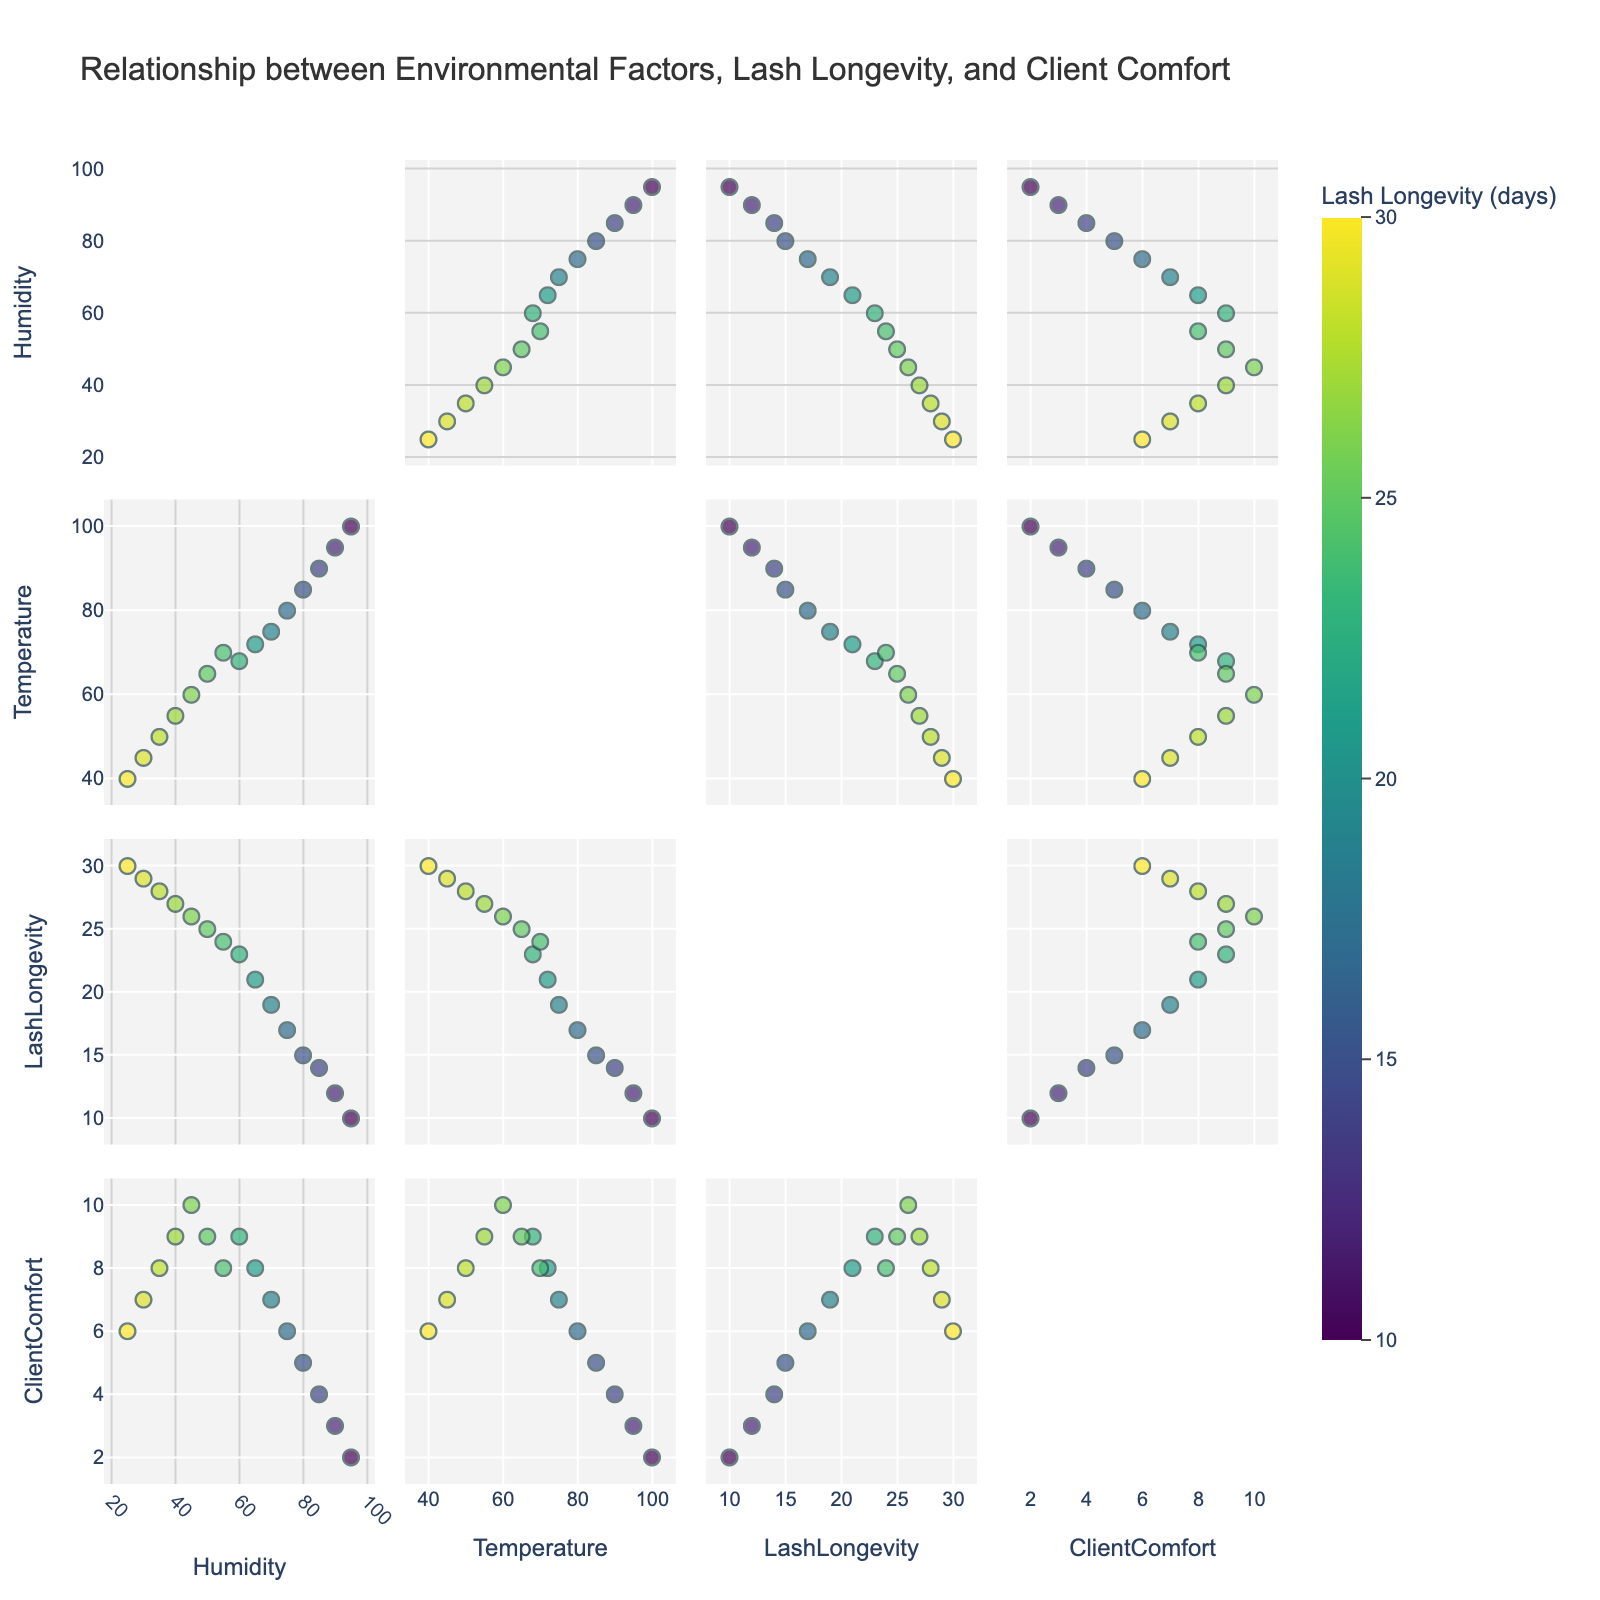What is the main title of the scatterplot matrix? The main title should be prominently displayed at the top of the scatterplot matrix. By reading this title, we can understand the overall subject of the plot.
Answer: Relationship between Environmental Factors, Lash Longevity, and Client Comfort How many dimensions are represented in the scatterplot matrix? Count the number of columns listed in the dimensions parameter of the scatterplot matrix, such as Humidity, Temperature, LashLongevity, and ClientComfort.
Answer: 4 What range of values does lash longevity span in the color scale? By examining the color bar on the scatterplot matrix, we can see the minimum and maximum values it represents, which indicate the range of lash longevity.
Answer: 10 to 30 Which pair of dimensions seems to have the strongest negative correlation? By visually inspecting the scatterplots in the matrix, look for pairs where the points trend downward, indicating that as one variable increases, the other decreases.
Answer: Humidity and LashLongevity What appears to be the general trend between temperature and client comfort levels? Analyzing the scatterplot of Temperature vs. Client Comfort, locate whether points generally trend upwards, downwards, or show no clear direction.
Answer: Negative correlation In which environmental condition, high humidity or low humidity, do lash extensions seem to last longer? By examining the scatterplot of Humidity vs. LashLongevity, identify whether points indicating longer lash longevity tend to cluster more toward higher or lower humidity values.
Answer: Low humidity What is the median lash longevity for the data points? Arrange the lash longevity values in ascending order and find the middle value, which represents the median.
Answer: 23 Does higher client comfort correlate more strongly with lower humidity or lower temperature? Compare the scatterplots of ClientComfort vs. Humidity and ClientComfort vs. Temperature for clustering of higher client comfort levels (higher y-axis values).
Answer: Lower humidity Which client comfort level range has the fewest data points, and what environmental factors might this correspond to? Look at the distribution of points along the ClientComfort axes and identify the range with the least points, then check corresponding scatterplots to infer associated environmental conditions.
Answer: 2-3, High humidity, and high temperature How do the points spread on the diagonal plots in this scatterplot matrix? Diagonal plots typically contain histograms or density plots of the individual dimensions; describe the pattern you see in these plots.
Answer: Diagonal not visible 